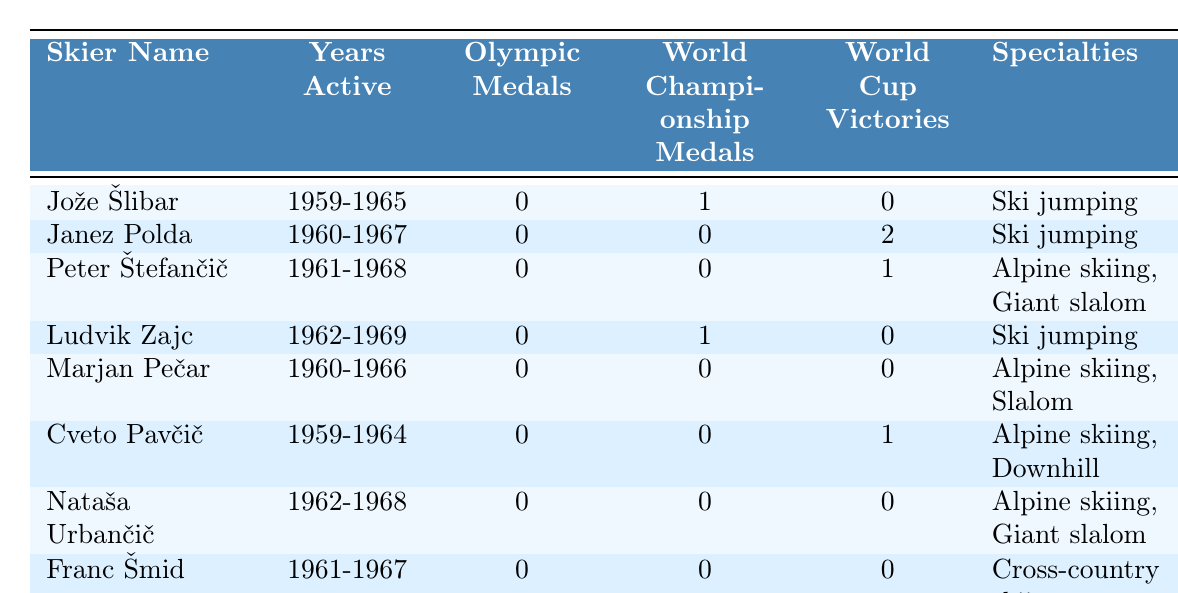What is the total number of Olympic medals won by the skiers listed? The table shows that all skiers have won 0 Olympic medals. Adding them gives a total of 0 Olympic medals.
Answer: 0 Which skier has the most World Cup victories? The table indicates that Janez Polda has 2 World Cup victories, which is more than any other skier listed.
Answer: Janez Polda How many skiers competed in Alpine skiing? Looking through the specialties, there are three skiers: Peter Štefančič, Marjan Pečar, and Cveto Pavčič, who are noted for Alpine skiing.
Answer: 3 Did any skier win both World Championship and World Cup medals? The skiers' records show that none of them have won World Championship medals and World Cup victories simultaneously.
Answer: No What is the average number of World Championship medals among the skiers? Adding the World Championship medals gives 1 (from Jože Šlibar and Ludvik Zajc), and there are 8 skiers. Thus, dividing the total by the number of skiers gives 1/8 = 0.125.
Answer: 0.125 Which skier specialized in cross-country skiing? Only Franc Šmid is listed as specializing in cross-country skiing among the table entries.
Answer: Franc Šmid How many skiers were active during the 1960s? The years active show that all listed skiers were active during the 1960s, particularly due to their start dates being in the late 1950s or early 1960s.
Answer: 8 Identify the skier who had the shortest active career. By comparing the years active, Cveto Pavčič (1959-1964) had the shortest career, spanning 5 years.
Answer: Cveto Pavčič What percentage of skiers won World Championship medals? Only Jože Šlibar and Ludvik Zajc won World Championship medals, which is 25% of the 8 total skiers: (2/8) * 100 = 25%.
Answer: 25% How many total World Cup victories were achieved by the athletes in the table? Adding the World Cup victories recorded gives a total of 3 (2 from Janez Polda and 1 from Peter Štefančič).
Answer: 3 